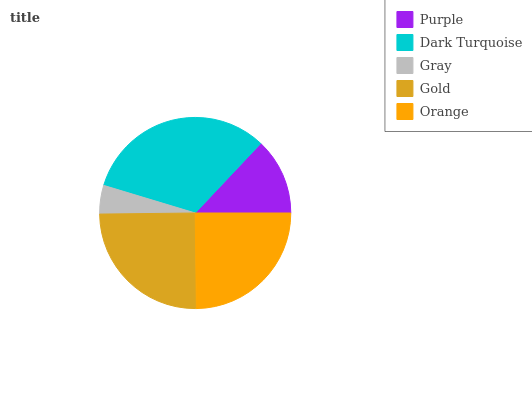Is Gray the minimum?
Answer yes or no. Yes. Is Dark Turquoise the maximum?
Answer yes or no. Yes. Is Dark Turquoise the minimum?
Answer yes or no. No. Is Gray the maximum?
Answer yes or no. No. Is Dark Turquoise greater than Gray?
Answer yes or no. Yes. Is Gray less than Dark Turquoise?
Answer yes or no. Yes. Is Gray greater than Dark Turquoise?
Answer yes or no. No. Is Dark Turquoise less than Gray?
Answer yes or no. No. Is Orange the high median?
Answer yes or no. Yes. Is Orange the low median?
Answer yes or no. Yes. Is Purple the high median?
Answer yes or no. No. Is Gold the low median?
Answer yes or no. No. 